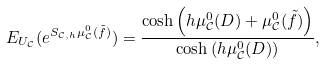<formula> <loc_0><loc_0><loc_500><loc_500>E _ { U _ { \mathcal { C } } } ( e ^ { S _ { \mathcal { C } , h } \mu ^ { 0 } _ { \mathcal { C } } ( \tilde { f } ) } ) = \frac { \cosh \left ( h \mu ^ { 0 } _ { \mathcal { C } } ( D ) + \mu ^ { 0 } _ { \mathcal { C } } ( \tilde { f } ) \right ) } { \cosh \left ( h \mu ^ { 0 } _ { \mathcal { C } } ( D ) \right ) } ,</formula> 